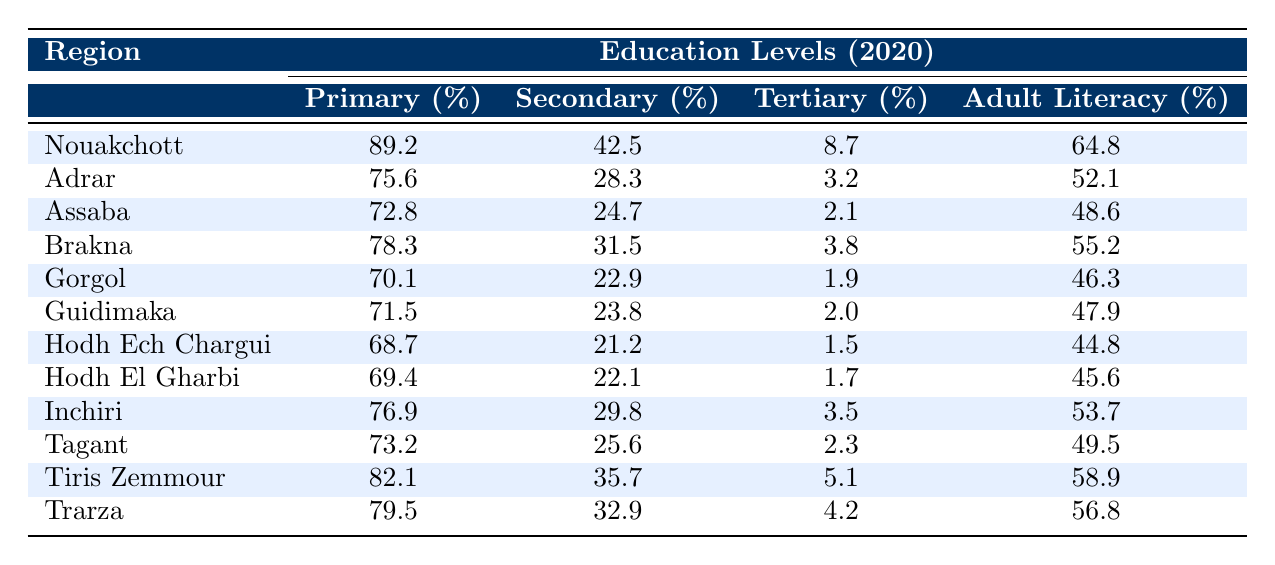What is the primary education percentage for women in Nouakchott? The table shows that the primary education percentage for women in Nouakchott is 89.2% as indicated in the respective row.
Answer: 89.2% Which region has the highest secondary education percentage for women? By comparing the secondary education percentages in each region from the table, Nouakchott has the highest at 42.5%.
Answer: Nouakchott What is the adult literacy rate percentage in Adrar? The table lists the adult literacy rate for Adrar as 52.1%, found in the corresponding row for that region.
Answer: 52.1% What is the difference between the primary education percentages of Tiris Zemmour and Gorgol? The primary education percentage for Tiris Zemmour is 82.1% and for Gorgol is 70.1%. The difference is 82.1% - 70.1% = 12.0%.
Answer: 12.0% Is the tertiary education percentage for women in Assaba less than 5%? The table shows that the tertiary education percentage in Assaba is 2.1%, which is indeed less than 5%.
Answer: Yes What is the average tertiary education percentage for women across all regions in the table? To find the average, sum all the tertiary education percentages: (8.7 + 3.2 + 2.1 + 3.8 + 1.9 + 2.0 + 1.5 + 1.7 + 3.5 + 2.3 + 5.1 + 4.2) = 35.0. There are 12 regions, so the average is 35.0 / 12 = 2.917.
Answer: 2.92 What region has the lowest adult literacy rate amongst the listed areas? Reviewing the adult literacy rates, Hodh Ech Chargui has the lowest rate listed at 44.8%.
Answer: Hodh Ech Chargui Which region shows a primary education percentage below 75% and has a secondary education percentage below 30%? By analyzing the data, both Assaba (72.8% primary, 24.7% secondary) and Gorgol (70.1% primary, 22.9% secondary) meet these criteria.
Answer: Assaba and Gorgol If we consider the regions with a tertiary education percentage higher than 4%, how many regions qualify? From the table, the regions with a tertiary education percentage over 4% are Tiris Zemmour (5.1%) and Trarza (4.2%), totaling 2 regions.
Answer: 2 What is the total percentage of women who have received at least primary education in all regions combined? To find this, we note that all regions report primary education percentages; however, we cannot add these together meaningfully as they represent different populations. Thus, this question is not directly answerable as a total percentage across all regions.
Answer: Not applicable 